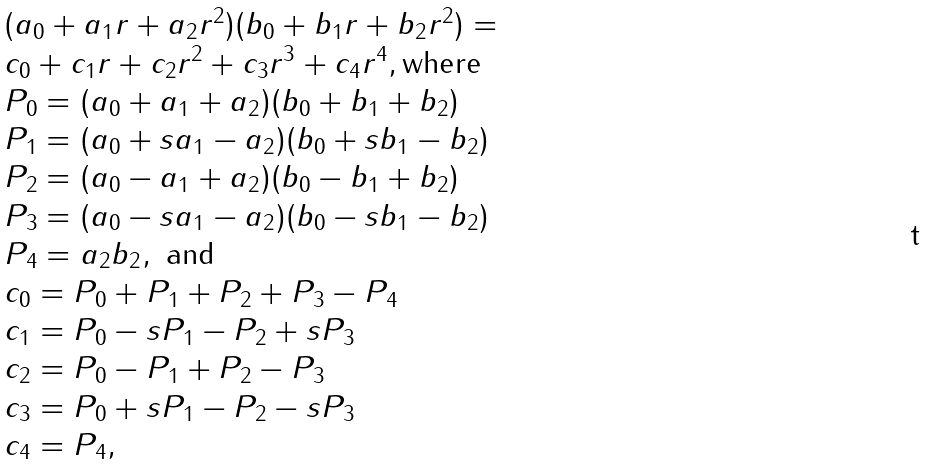<formula> <loc_0><loc_0><loc_500><loc_500>\begin{array} { l } ( a _ { 0 } + a _ { 1 } r + a _ { 2 } r ^ { 2 } ) ( b _ { 0 } + b _ { 1 } r + b _ { 2 } r ^ { 2 } ) = \\ c _ { 0 } + c _ { 1 } r + c _ { 2 } r ^ { 2 } + c _ { 3 } r ^ { 3 } + c _ { 4 } r ^ { 4 } , \text {where} \\ P _ { 0 } = ( a _ { 0 } + a _ { 1 } + a _ { 2 } ) ( b _ { 0 } + b _ { 1 } + b _ { 2 } ) \\ P _ { 1 } = ( a _ { 0 } + s a _ { 1 } - a _ { 2 } ) ( b _ { 0 } + s b _ { 1 } - b _ { 2 } ) \\ P _ { 2 } = ( a _ { 0 } - a _ { 1 } + a _ { 2 } ) ( b _ { 0 } - b _ { 1 } + b _ { 2 } ) \\ P _ { 3 } = ( a _ { 0 } - s a _ { 1 } - a _ { 2 } ) ( b _ { 0 } - s b _ { 1 } - b _ { 2 } ) \\ P _ { 4 } = a _ { 2 } b _ { 2 } , \text { and} \\ c _ { 0 } = P _ { 0 } + P _ { 1 } + P _ { 2 } + P _ { 3 } - P _ { 4 } \\ c _ { 1 } = P _ { 0 } - s P _ { 1 } - P _ { 2 } + s P _ { 3 } \\ c _ { 2 } = P _ { 0 } - P _ { 1 } + P _ { 2 } - P _ { 3 } \\ c _ { 3 } = P _ { 0 } + s P _ { 1 } - P _ { 2 } - s P _ { 3 } \\ c _ { 4 } = P _ { 4 } , \end{array}</formula> 